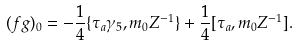Convert formula to latex. <formula><loc_0><loc_0><loc_500><loc_500>( f g ) _ { 0 } = - \frac { 1 } { 4 } \{ \tau _ { a } \gamma _ { 5 } , m _ { 0 } Z ^ { - 1 } \} + \frac { 1 } { 4 } [ \tau _ { a } , m _ { 0 } Z ^ { - 1 } ] .</formula> 